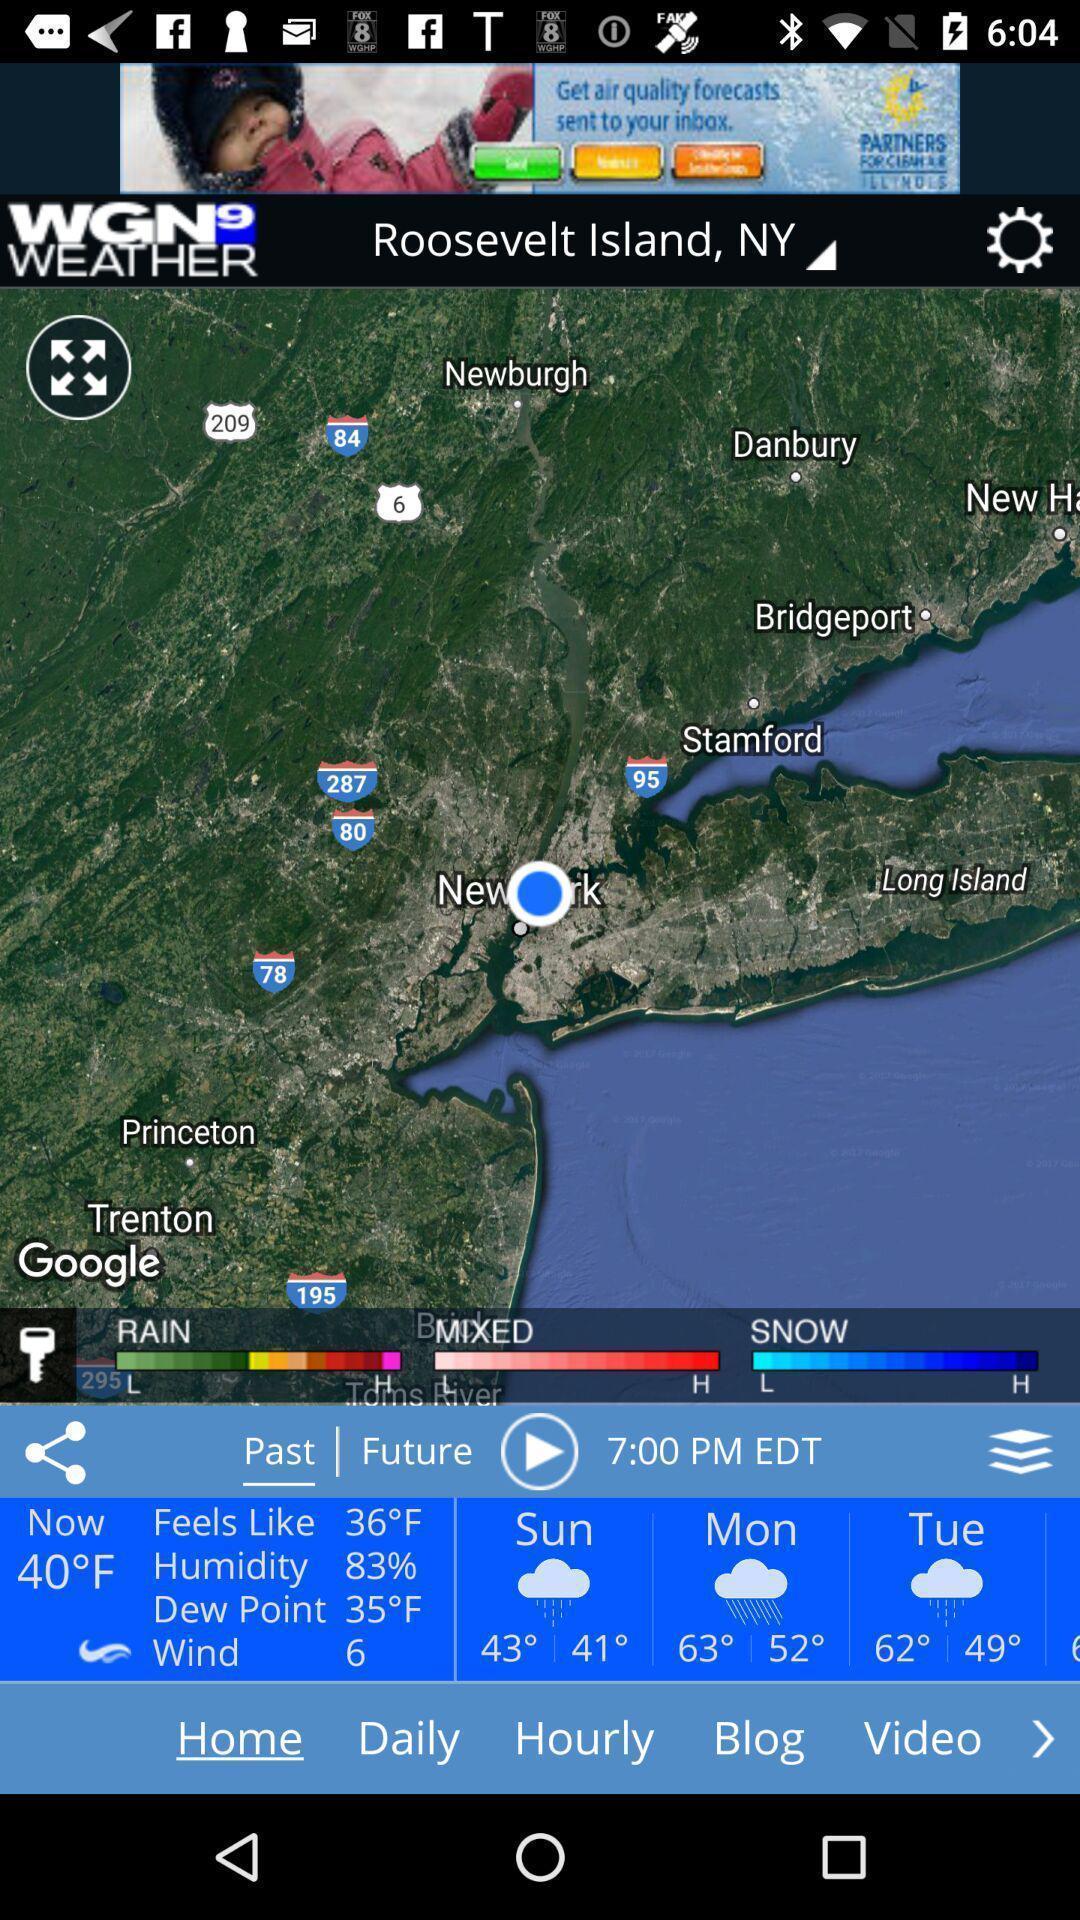Provide a detailed account of this screenshot. Page showing weather forecast in map. 